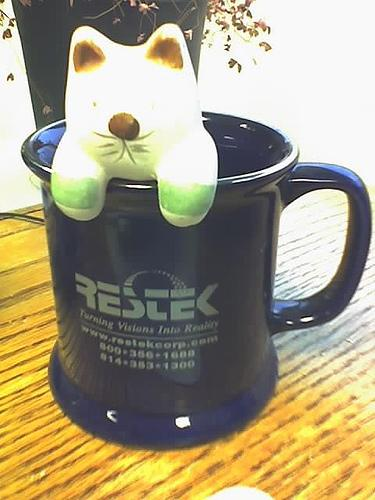Where is Restek's headquarters? Please explain your reasoning. california. A logo is on a mug with an address as well. 